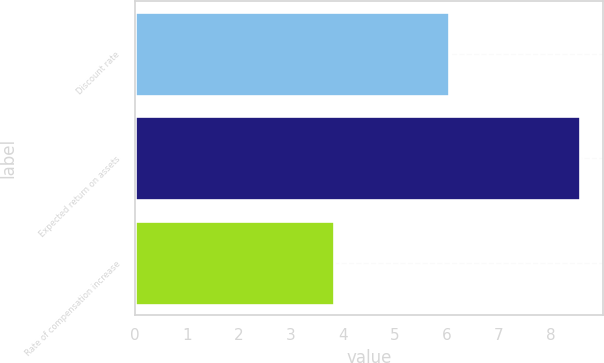Convert chart. <chart><loc_0><loc_0><loc_500><loc_500><bar_chart><fcel>Discount rate<fcel>Expected return on assets<fcel>Rate of compensation increase<nl><fcel>6.03<fcel>8.57<fcel>3.83<nl></chart> 